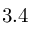<formula> <loc_0><loc_0><loc_500><loc_500>3 . 4</formula> 